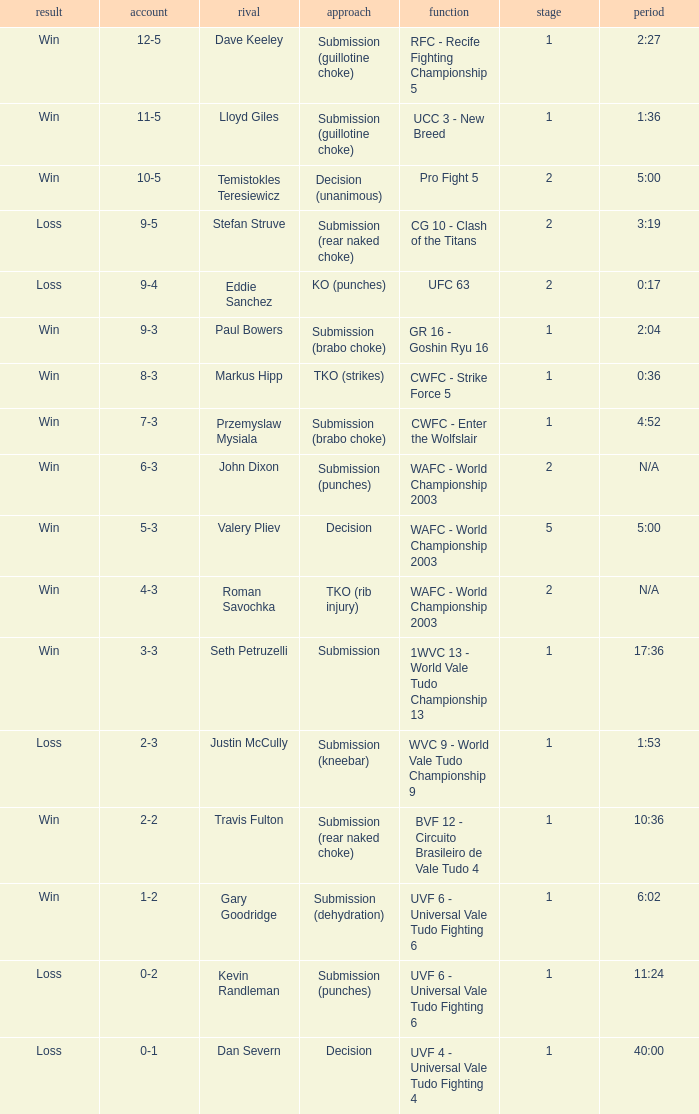What opponent uses the method of decision and a 5-3 record? Valery Pliev. 